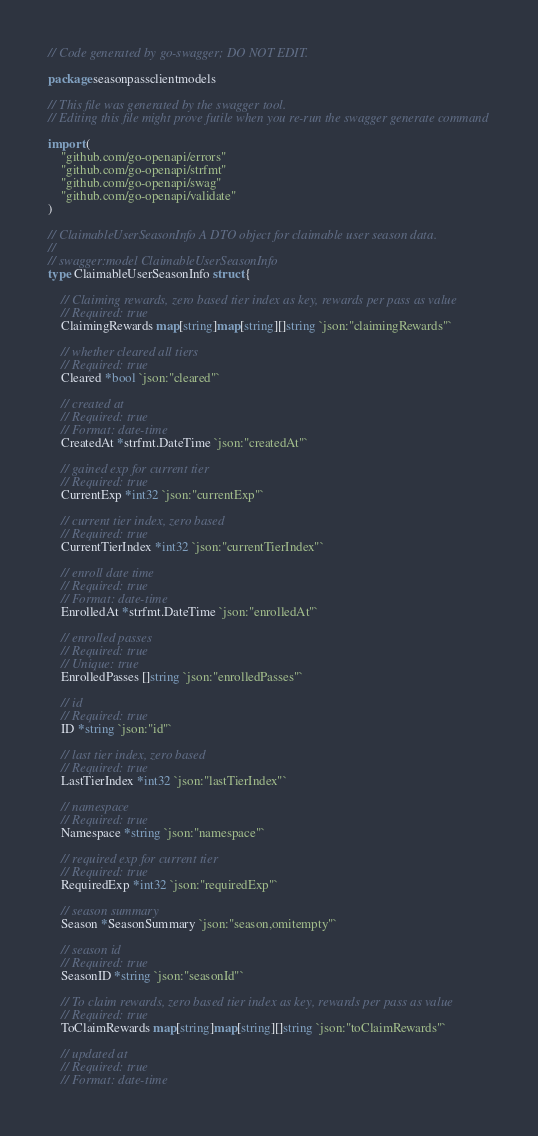<code> <loc_0><loc_0><loc_500><loc_500><_Go_>// Code generated by go-swagger; DO NOT EDIT.

package seasonpassclientmodels

// This file was generated by the swagger tool.
// Editing this file might prove futile when you re-run the swagger generate command

import (
	"github.com/go-openapi/errors"
	"github.com/go-openapi/strfmt"
	"github.com/go-openapi/swag"
	"github.com/go-openapi/validate"
)

// ClaimableUserSeasonInfo A DTO object for claimable user season data.
//
// swagger:model ClaimableUserSeasonInfo
type ClaimableUserSeasonInfo struct {

	// Claiming rewards, zero based tier index as key, rewards per pass as value
	// Required: true
	ClaimingRewards map[string]map[string][]string `json:"claimingRewards"`

	// whether cleared all tiers
	// Required: true
	Cleared *bool `json:"cleared"`

	// created at
	// Required: true
	// Format: date-time
	CreatedAt *strfmt.DateTime `json:"createdAt"`

	// gained exp for current tier
	// Required: true
	CurrentExp *int32 `json:"currentExp"`

	// current tier index, zero based
	// Required: true
	CurrentTierIndex *int32 `json:"currentTierIndex"`

	// enroll date time
	// Required: true
	// Format: date-time
	EnrolledAt *strfmt.DateTime `json:"enrolledAt"`

	// enrolled passes
	// Required: true
	// Unique: true
	EnrolledPasses []string `json:"enrolledPasses"`

	// id
	// Required: true
	ID *string `json:"id"`

	// last tier index, zero based
	// Required: true
	LastTierIndex *int32 `json:"lastTierIndex"`

	// namespace
	// Required: true
	Namespace *string `json:"namespace"`

	// required exp for current tier
	// Required: true
	RequiredExp *int32 `json:"requiredExp"`

	// season summary
	Season *SeasonSummary `json:"season,omitempty"`

	// season id
	// Required: true
	SeasonID *string `json:"seasonId"`

	// To claim rewards, zero based tier index as key, rewards per pass as value
	// Required: true
	ToClaimRewards map[string]map[string][]string `json:"toClaimRewards"`

	// updated at
	// Required: true
	// Format: date-time</code> 